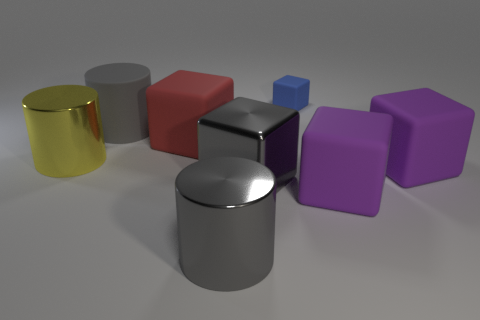Subtract 1 blocks. How many blocks are left? 4 Subtract all red cubes. How many cubes are left? 4 Subtract all gray metallic blocks. How many blocks are left? 4 Subtract all blue cylinders. Subtract all gray cubes. How many cylinders are left? 3 Add 2 small blue objects. How many objects exist? 10 Subtract all cubes. How many objects are left? 3 Add 2 big rubber cubes. How many big rubber cubes exist? 5 Subtract 0 blue balls. How many objects are left? 8 Subtract all blue rubber cubes. Subtract all large shiny blocks. How many objects are left? 6 Add 1 large gray cylinders. How many large gray cylinders are left? 3 